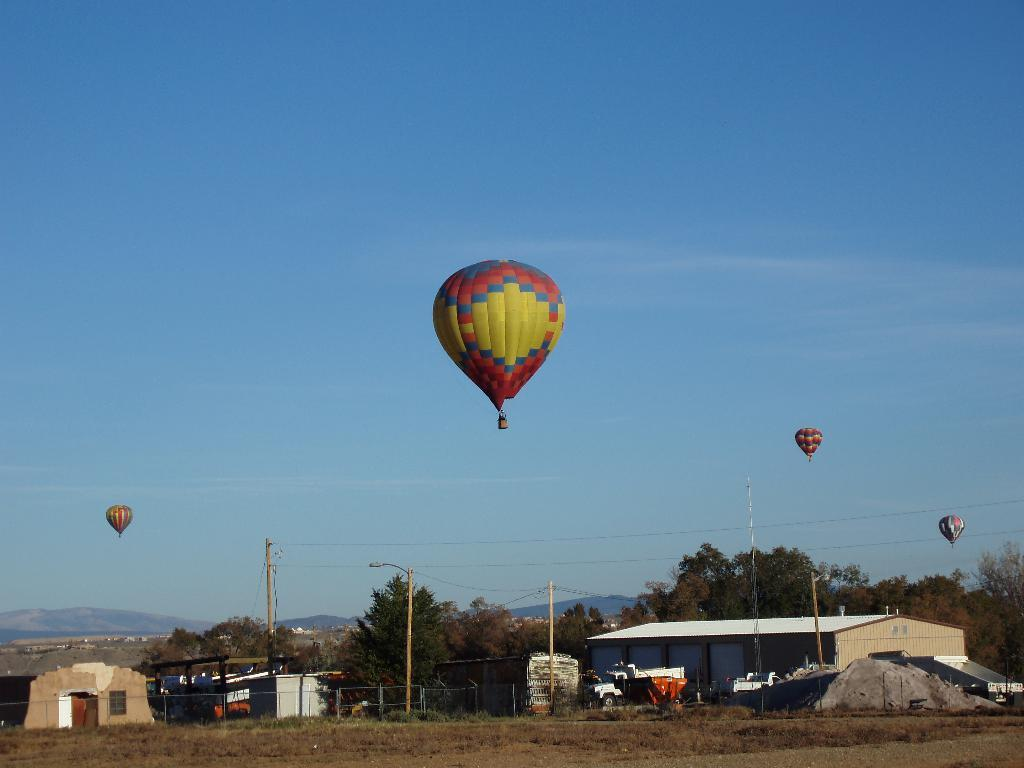What is the main subject of the image? The main subject of the image is hot air balloons. What is located beneath the hot air balloons? There are houses under the hot air balloons. What type of poles can be seen in the image? Electric poles are present in the image. What connects the electric poles in the image? Cables are visible in the image. What is visible at the top of the image? The sky is visible at the top of the image. Where is the nest of the bird that is using the kettle in the image? There is no bird or kettle present in the image, so there is no nest to locate. What type of operation is being performed on the hot air balloons in the image? There is no operation being performed on the hot air balloons in the image; they are simply floating in the sky. 